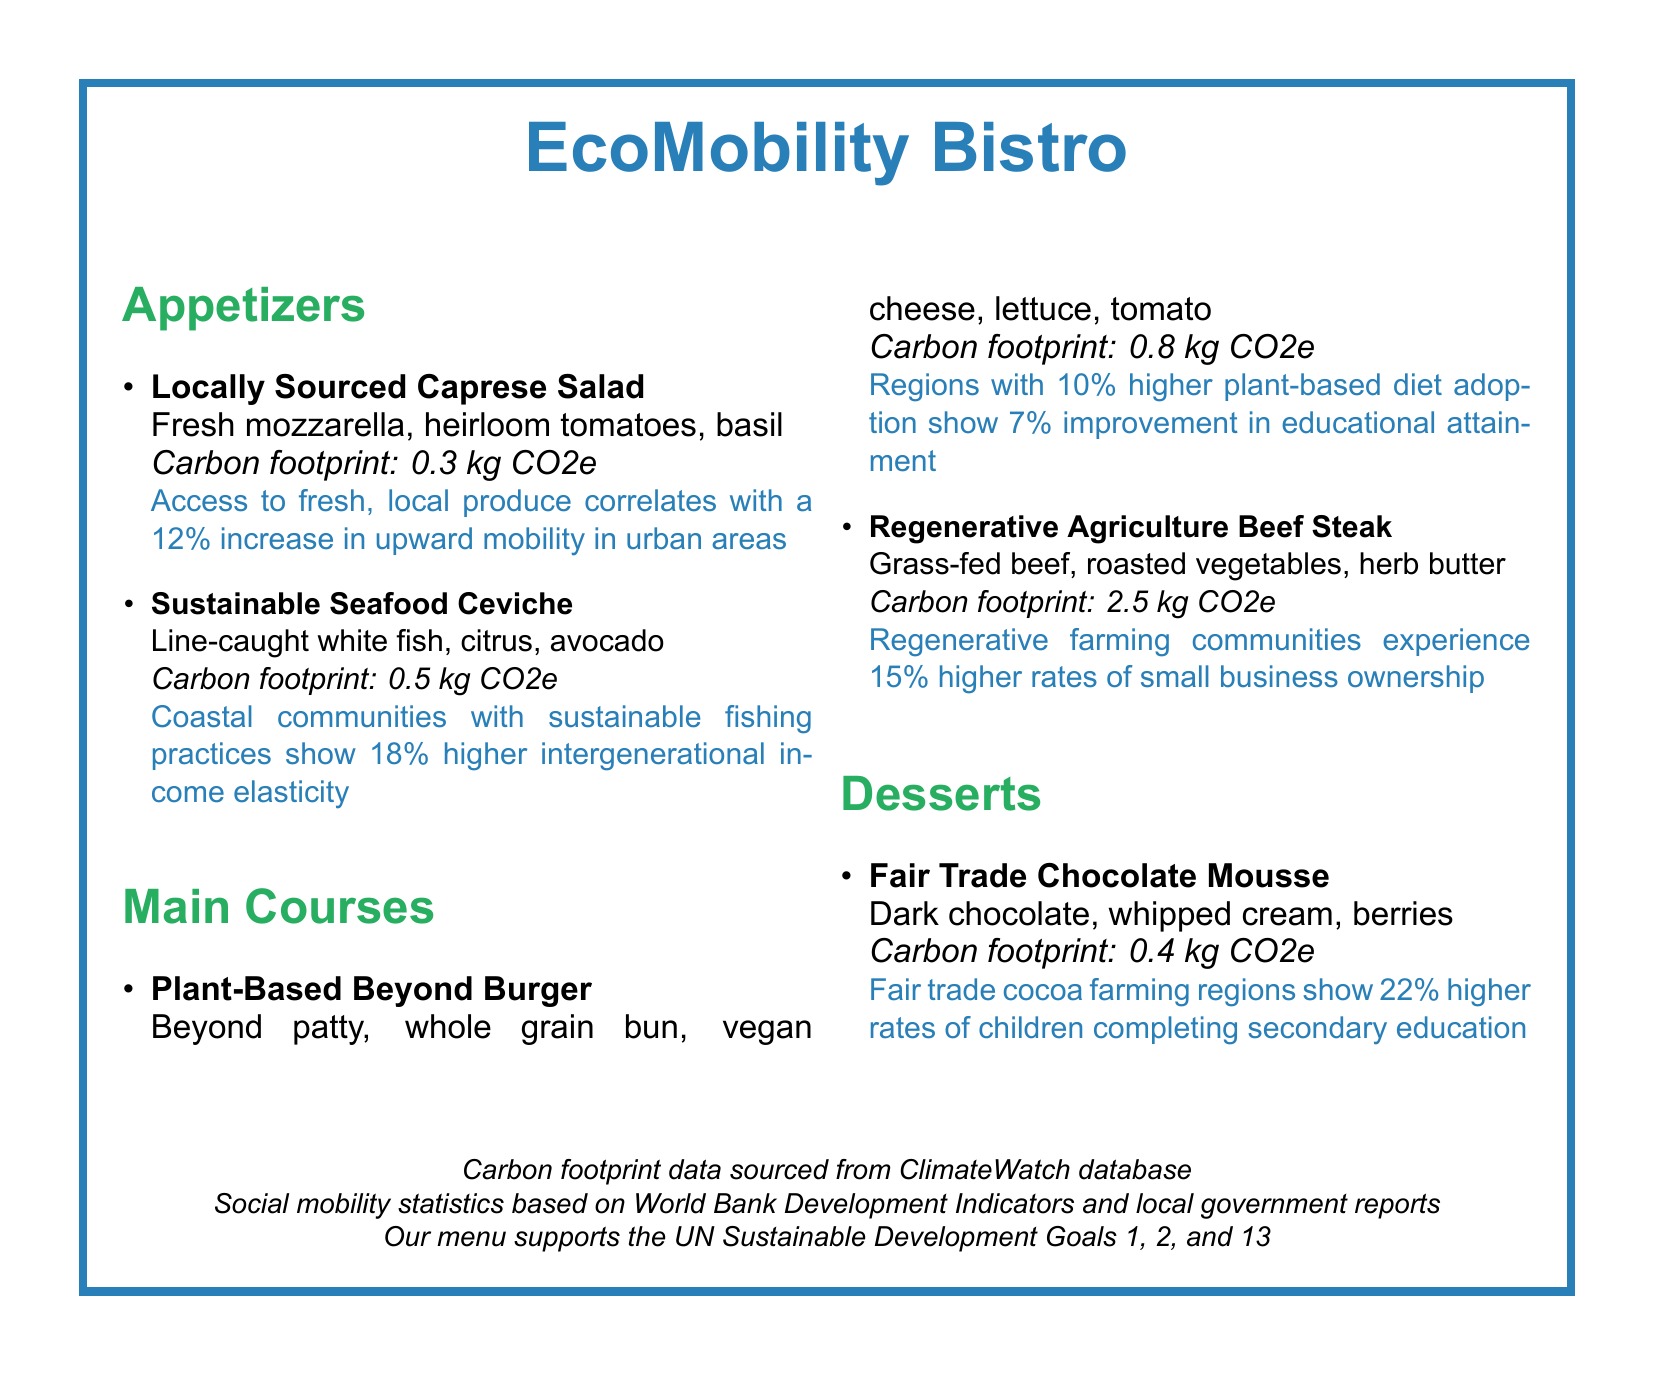What is the carbon footprint of the Sustainable Seafood Ceviche? The carbon footprint for the Sustainable Seafood Ceviche is specified in the document.
Answer: 0.5 kg CO2e What percentage of upward mobility is correlated with access to fresh, local produce? The document provides a statistic related to the impact of fresh, local produce on upward mobility.
Answer: 12% What type of meat is used in the Regenerative Agriculture Beef Steak? The document mentions the type of meat used in this dish.
Answer: Grass-fed beef Which dessert features Fair Trade chocolate? The document lists desserts and identifies the one featuring Fair Trade chocolate.
Answer: Fair Trade Chocolate Mousse What environmental factor is associated with 22% higher secondary education completion rates? The document relates a specific statistic to a type of farming practice.
Answer: Fair trade cocoa farming What improvement in educational attainment is observed with a diet adoption of 10% higher plant-based foods? The document provides statistics on educational attainment improvement related to dietary habits.
Answer: 7% 